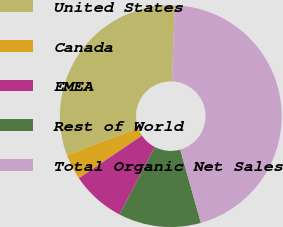<chart> <loc_0><loc_0><loc_500><loc_500><pie_chart><fcel>United States<fcel>Canada<fcel>EMEA<fcel>Rest of World<fcel>Total Organic Net Sales<nl><fcel>31.28%<fcel>3.76%<fcel>7.89%<fcel>12.02%<fcel>45.06%<nl></chart> 